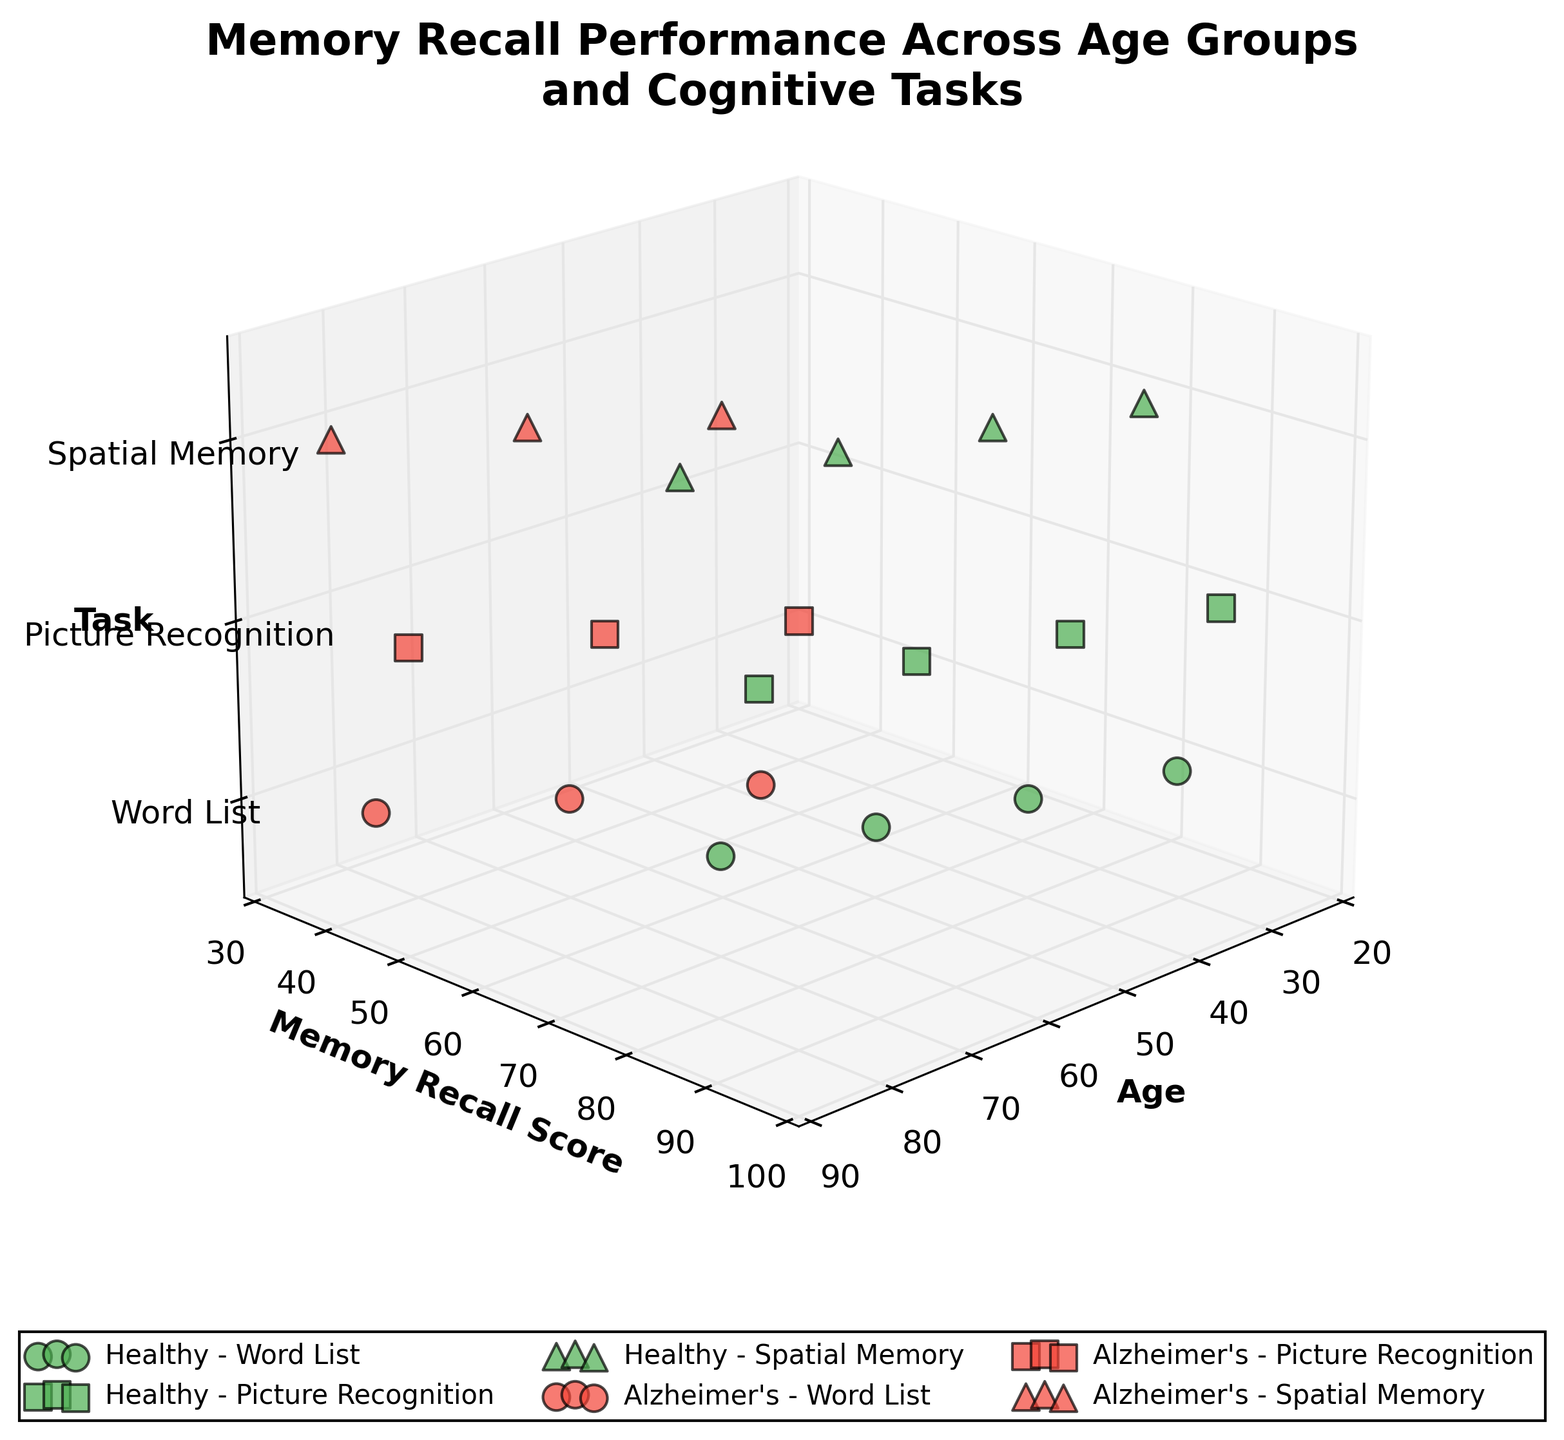What is the title of the figure? The title is usually located at the top of the figure. In this case, it is displayed as 'Memory Recall Performance Across Age Groups and Cognitive Tasks'.
Answer: Memory Recall Performance Across Age Groups and Cognitive Tasks Which axis represents the age groups? The x-axis label indicates which variable is represented. Here, the x-axis is labeled 'Age'.
Answer: x-axis What represents the condition of the participants in the plot? The color of the scatter points represents different conditions. The figure legend shows green points for 'Healthy' and red points for 'Alzheimer's'.
Answer: Colors How does memory recall performance in the 'Word List' task for healthy individuals change with age? By looking at the scatter points for 'Healthy' in 'Word List' (green circles), we can see that memory recall scores decrease as age increases from 25 to 70 years.
Answer: Decreases with age What is the memory recall score for 70-year-olds with Alzheimer's in the 'Spatial Memory' task? Find the red triangle at the coordinate where age is 70. The memory recall score listed next to the point is 45.
Answer: 45 Compare the recall performance in 'Picture Recognition' between 55-year-olds with and without Alzheimer's. By comparing the green square (Healthy, 80) to the red square (Alzheimer's, 65) at age 55, we see that healthy individuals perform better.
Answer: Healthy: 80, Alzheimer's: 65 What task has the highest memory recall score among 25-year-olds without Alzheimer's? By locating the green points for age 25 on the plot, the highest point represents a score of 90, which is for 'Picture Recognition' (green square).
Answer: Picture Recognition What is the difference in recall scores in 'Word List' task between 85-year-olds with Alzheimer's and 40-year-olds without Alzheimer's? 'Word List' task points for 85-year-olds with Alzheimer's (red circle, 40) and for 40-year-olds without Alzheimer's (green circle, 80), the difference is 80 - 40 = 40.
Answer: 40 How do the memory recall scores for 'Spatial Memory' change with increasing age in people with Alzheimer's? Follow the red triangles corresponding to 'Spatial Memory'. The memory recall scores drop from 55 (age 55) to 45 (age 70) to 35 (age 85).
Answer: Decrease with age Which task among the listed shows the least decline in memory recall scores from age 25 to 70 for healthy subjects? By comparing the slopes formed by green markers from age 25 to 70, 'Picture Recognition' (green square, from 90 to 75) shows the smallest decline.
Answer: Picture Recognition 